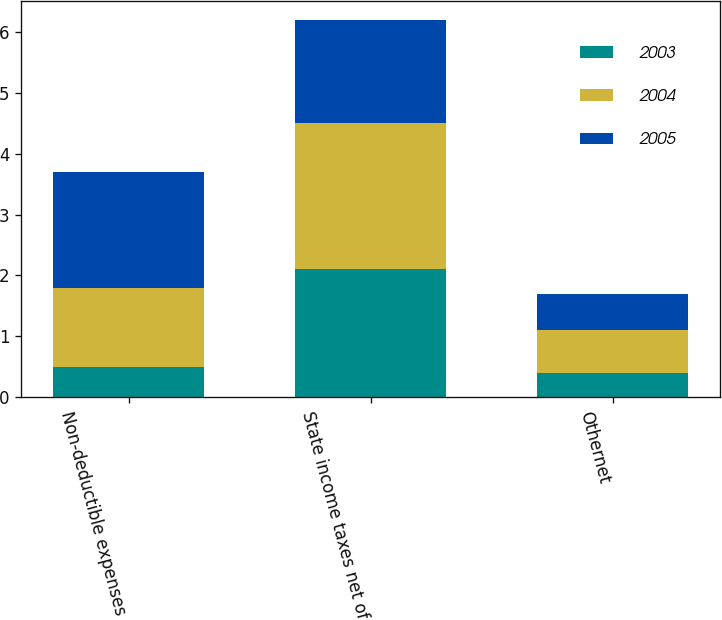Convert chart to OTSL. <chart><loc_0><loc_0><loc_500><loc_500><stacked_bar_chart><ecel><fcel>Non-deductible expenses<fcel>State income taxes net of<fcel>Othernet<nl><fcel>2003<fcel>0.5<fcel>2.1<fcel>0.4<nl><fcel>2004<fcel>1.3<fcel>2.4<fcel>0.7<nl><fcel>2005<fcel>1.9<fcel>1.7<fcel>0.6<nl></chart> 